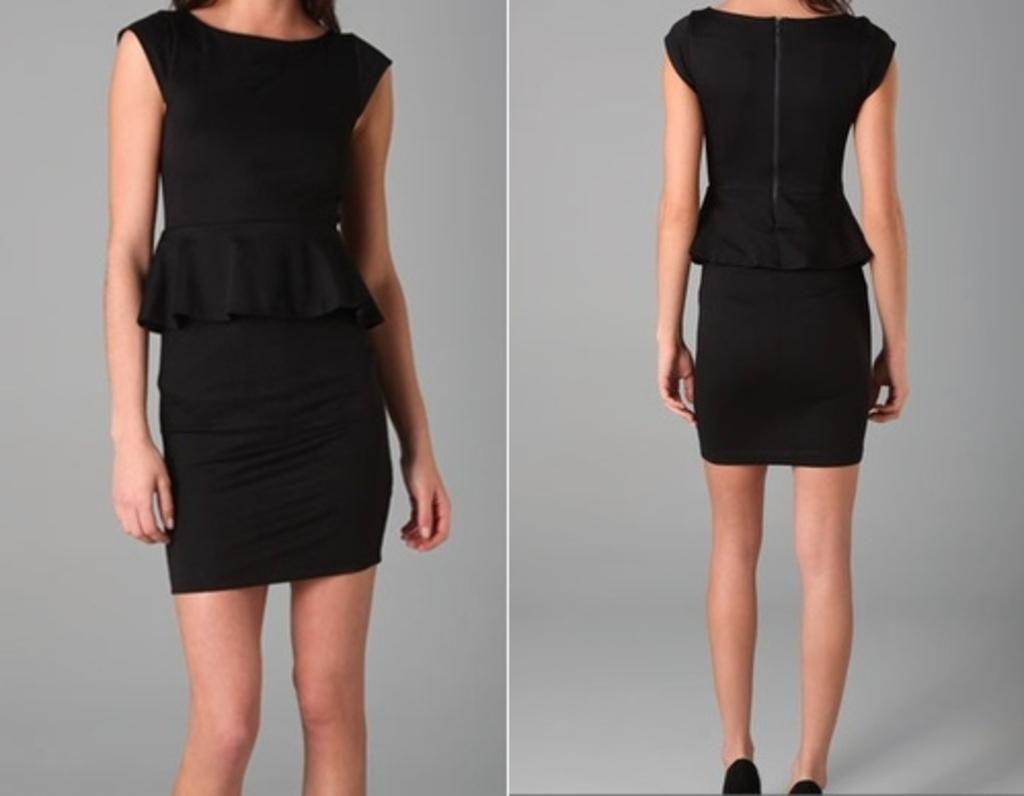What type of image is shown in the picture? The image is a collage. Can you describe the person in the image? There is a person in the image. What is the person wearing in the image? The person is wearing a black dress. What type of knife is being used to peel the yam in the image? There is no knife or yam present in the image. How many thumbs does the person have in the image? The number of thumbs the person has cannot be determined from the image. 